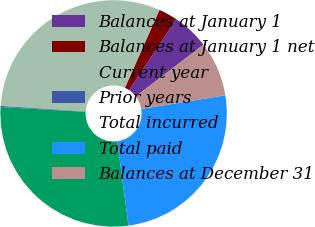Convert chart to OTSL. <chart><loc_0><loc_0><loc_500><loc_500><pie_chart><fcel>Balances at January 1<fcel>Balances at January 1 net<fcel>Current year<fcel>Prior years<fcel>Total incurred<fcel>Total paid<fcel>Balances at December 31<nl><fcel>5.27%<fcel>2.7%<fcel>30.59%<fcel>0.14%<fcel>28.02%<fcel>25.46%<fcel>7.83%<nl></chart> 